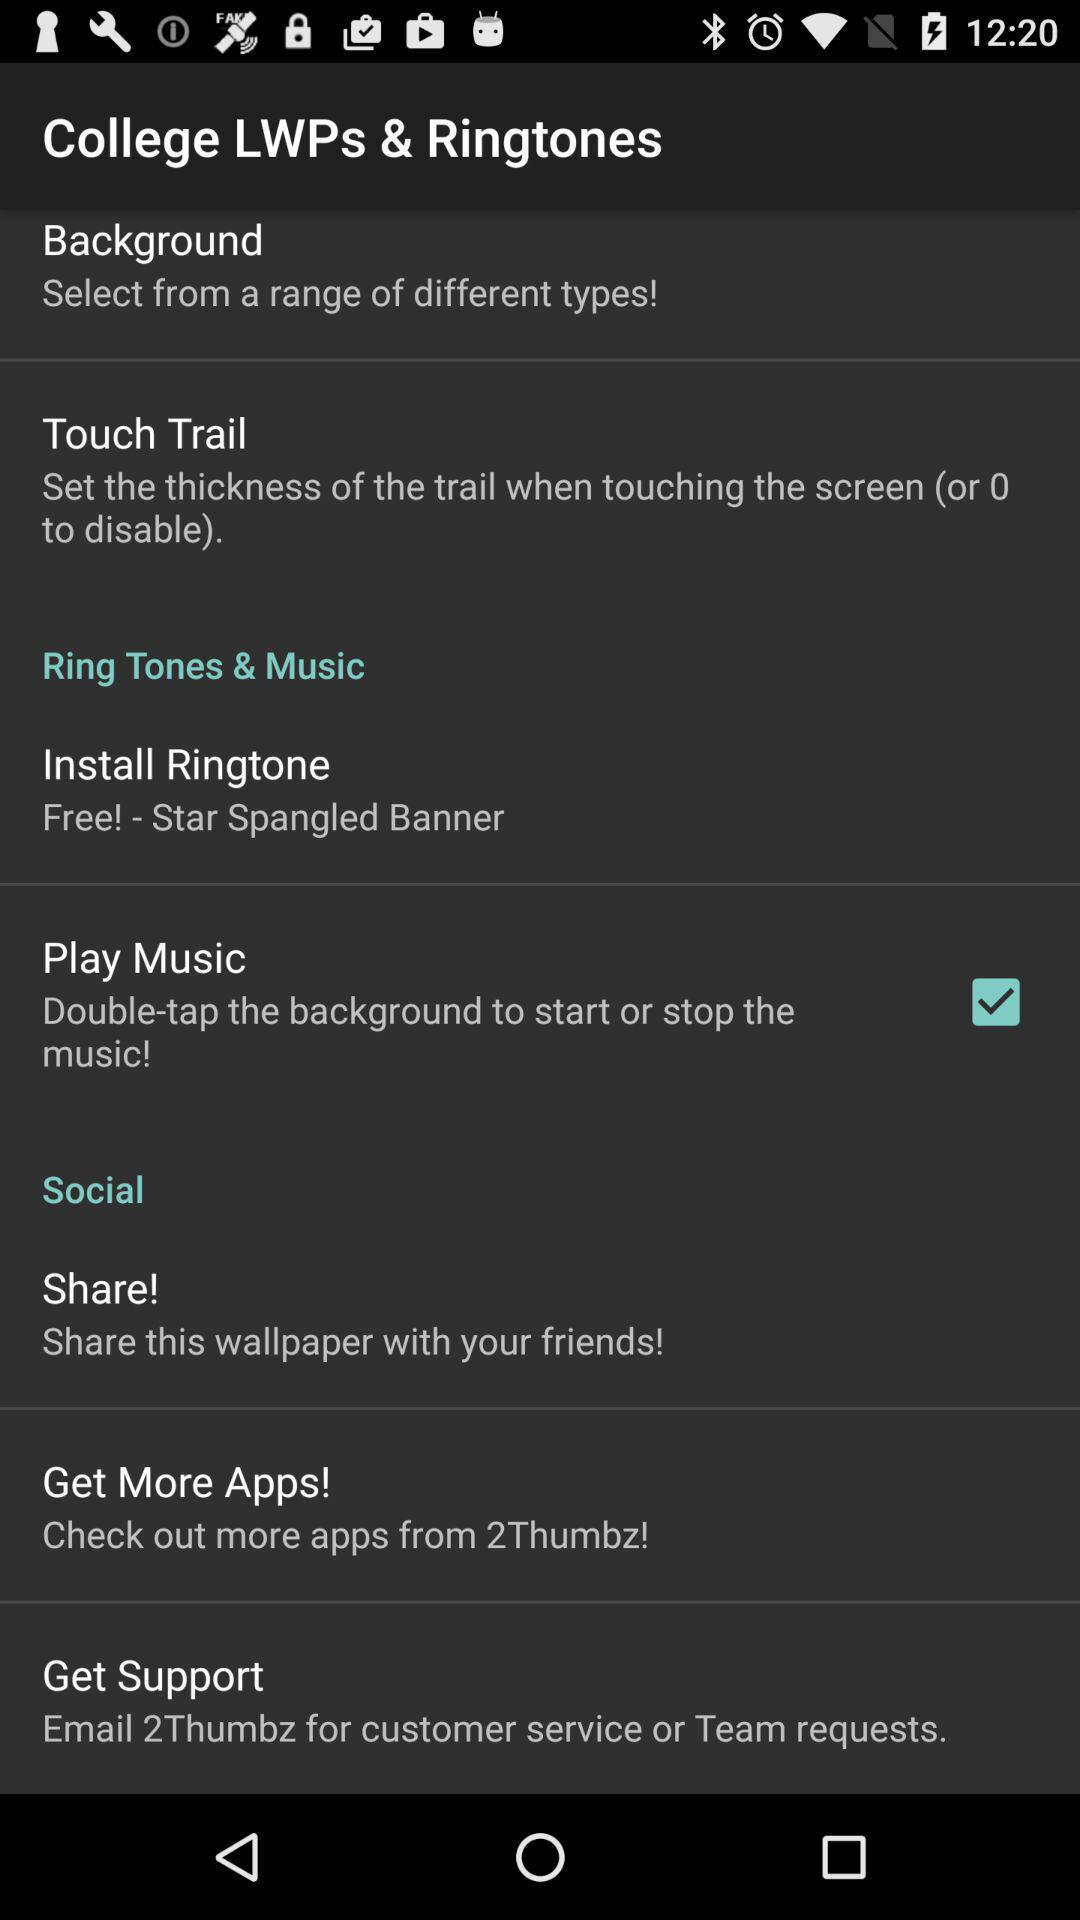Where should the email be sent for support? The email should be sent to "2Thumbz" for support. 